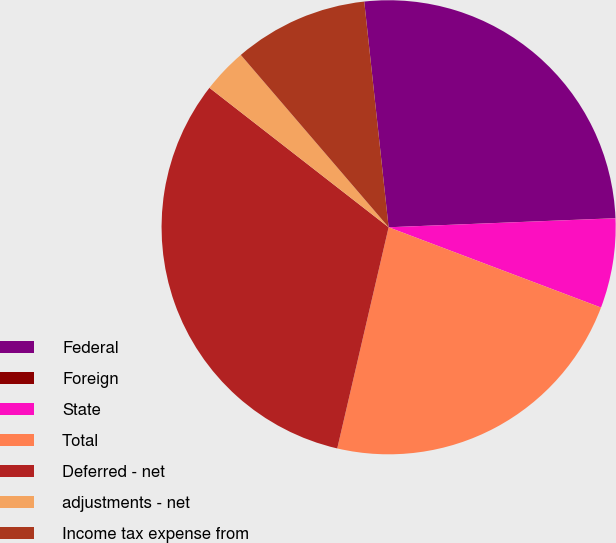<chart> <loc_0><loc_0><loc_500><loc_500><pie_chart><fcel>Federal<fcel>Foreign<fcel>State<fcel>Total<fcel>Deferred - net<fcel>adjustments - net<fcel>Income tax expense from<nl><fcel>26.07%<fcel>0.01%<fcel>6.38%<fcel>22.88%<fcel>31.89%<fcel>3.19%<fcel>9.57%<nl></chart> 